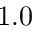<formula> <loc_0><loc_0><loc_500><loc_500>1 . 0</formula> 